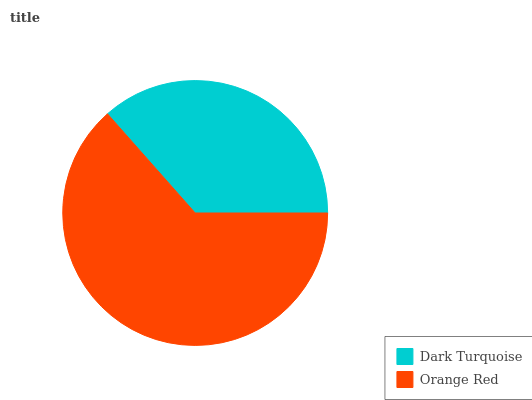Is Dark Turquoise the minimum?
Answer yes or no. Yes. Is Orange Red the maximum?
Answer yes or no. Yes. Is Orange Red the minimum?
Answer yes or no. No. Is Orange Red greater than Dark Turquoise?
Answer yes or no. Yes. Is Dark Turquoise less than Orange Red?
Answer yes or no. Yes. Is Dark Turquoise greater than Orange Red?
Answer yes or no. No. Is Orange Red less than Dark Turquoise?
Answer yes or no. No. Is Orange Red the high median?
Answer yes or no. Yes. Is Dark Turquoise the low median?
Answer yes or no. Yes. Is Dark Turquoise the high median?
Answer yes or no. No. Is Orange Red the low median?
Answer yes or no. No. 